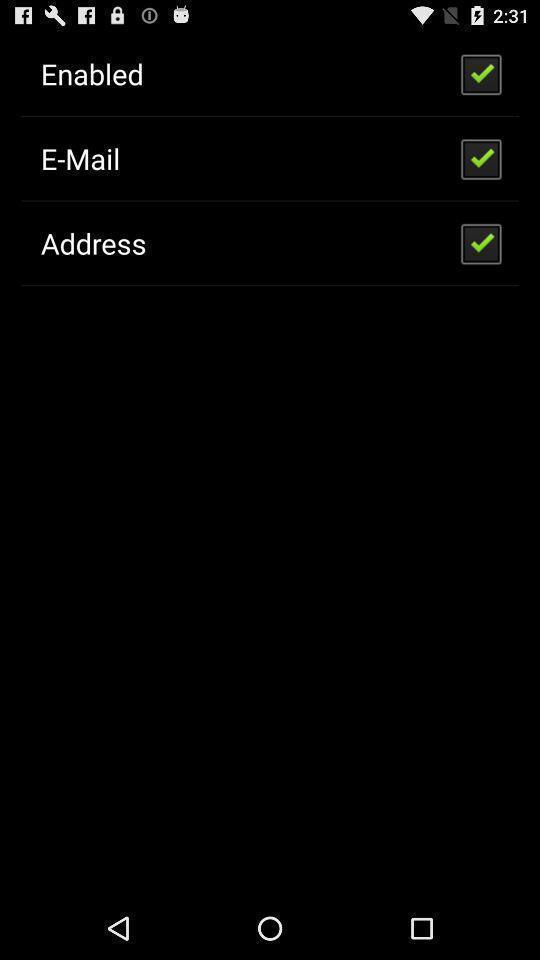Describe the visual elements of this screenshot. Page showing various options. 